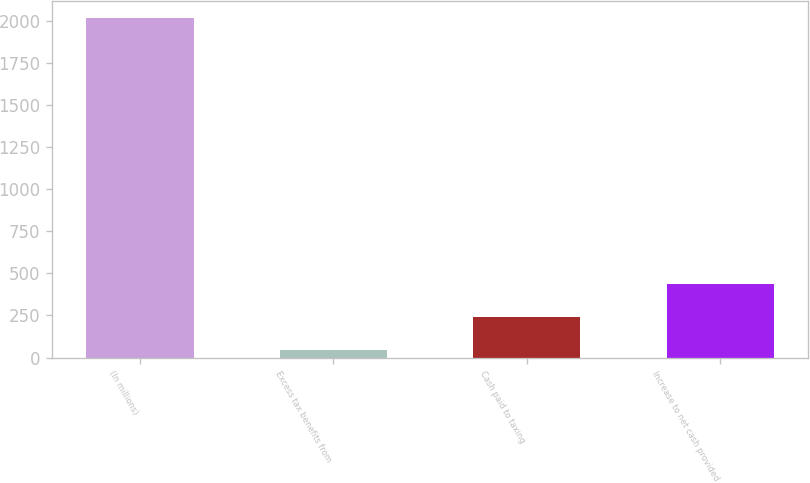<chart> <loc_0><loc_0><loc_500><loc_500><bar_chart><fcel>(In millions)<fcel>Excess tax benefits from<fcel>Cash paid to taxing<fcel>Increase to net cash provided<nl><fcel>2018<fcel>43<fcel>240.5<fcel>438<nl></chart> 